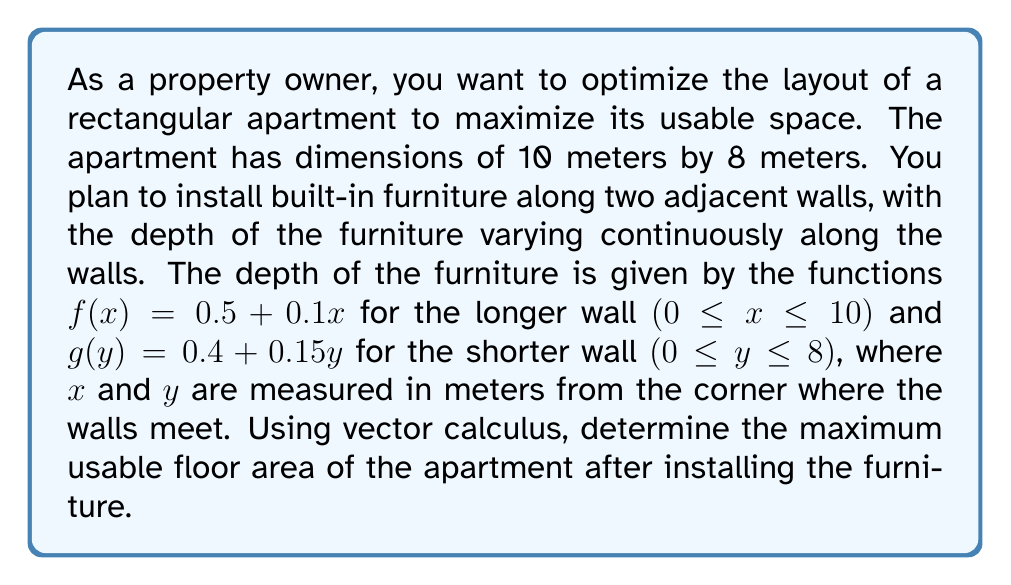Can you answer this question? To solve this problem, we'll use the following steps:

1) First, we need to set up the double integral that represents the usable floor area. The area will be the total area minus the area occupied by the furniture.

2) The total area is simply 10 * 8 = 80 square meters.

3) To find the area occupied by the furniture, we need to integrate the depth functions along their respective walls:

   For the longer wall: $\int_0^{10} f(x) dx = \int_0^{10} (0.5 + 0.1x) dx$
   For the shorter wall: $\int_0^8 g(y) dy = \int_0^8 (0.4 + 0.15y) dy$

4) Let's calculate these integrals:

   $\int_0^{10} (0.5 + 0.1x) dx = [0.5x + 0.05x^2]_0^{10} = (5 + 5) - (0 + 0) = 10$ sq meters

   $\int_0^8 (0.4 + 0.15y) dy = [0.4y + 0.075y^2]_0^8 = (3.2 + 4.8) - (0 + 0) = 8$ sq meters

5) The total area occupied by furniture is thus 10 + 8 = 18 sq meters.

6) Therefore, the maximum usable floor area is:
   
   Total area - Area occupied by furniture = 80 - 18 = 62 sq meters

Note: We didn't need to use a double integral in this case because the furniture depth functions were independent of each other. If they were interdependent, we would have needed to set up and solve a double integral.
Answer: The maximum usable floor area of the apartment after installing the furniture is 62 square meters. 